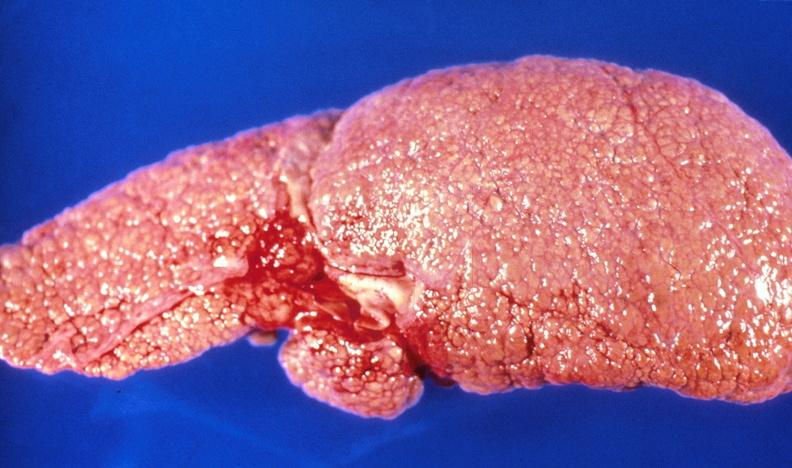s acute peritonitis present?
Answer the question using a single word or phrase. No 